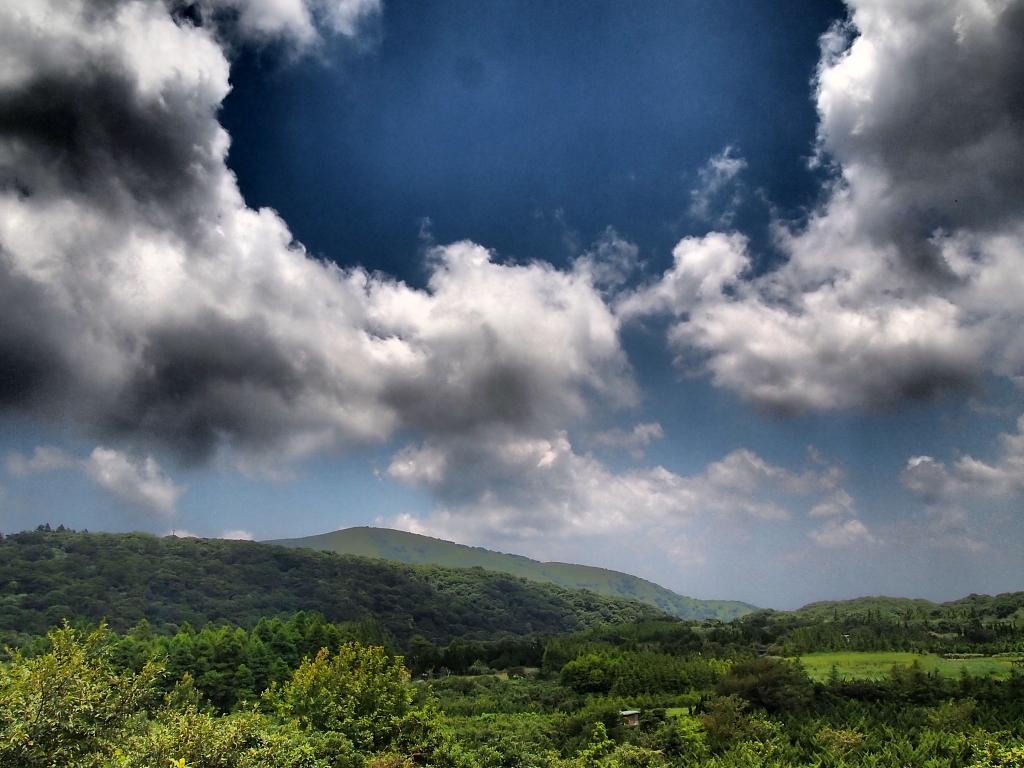What type of vegetation can be seen in the image? There are plants and trees in the image. What type of landscape feature is present in the image? There are hills in the image. What is visible in the background of the image? The sky is visible in the background of the image. What type of stove is visible in the image? There is no stove present in the image. How many apples are hanging from the trees in the image? There is no mention of apples in the image; it features plants, trees, and hills. 